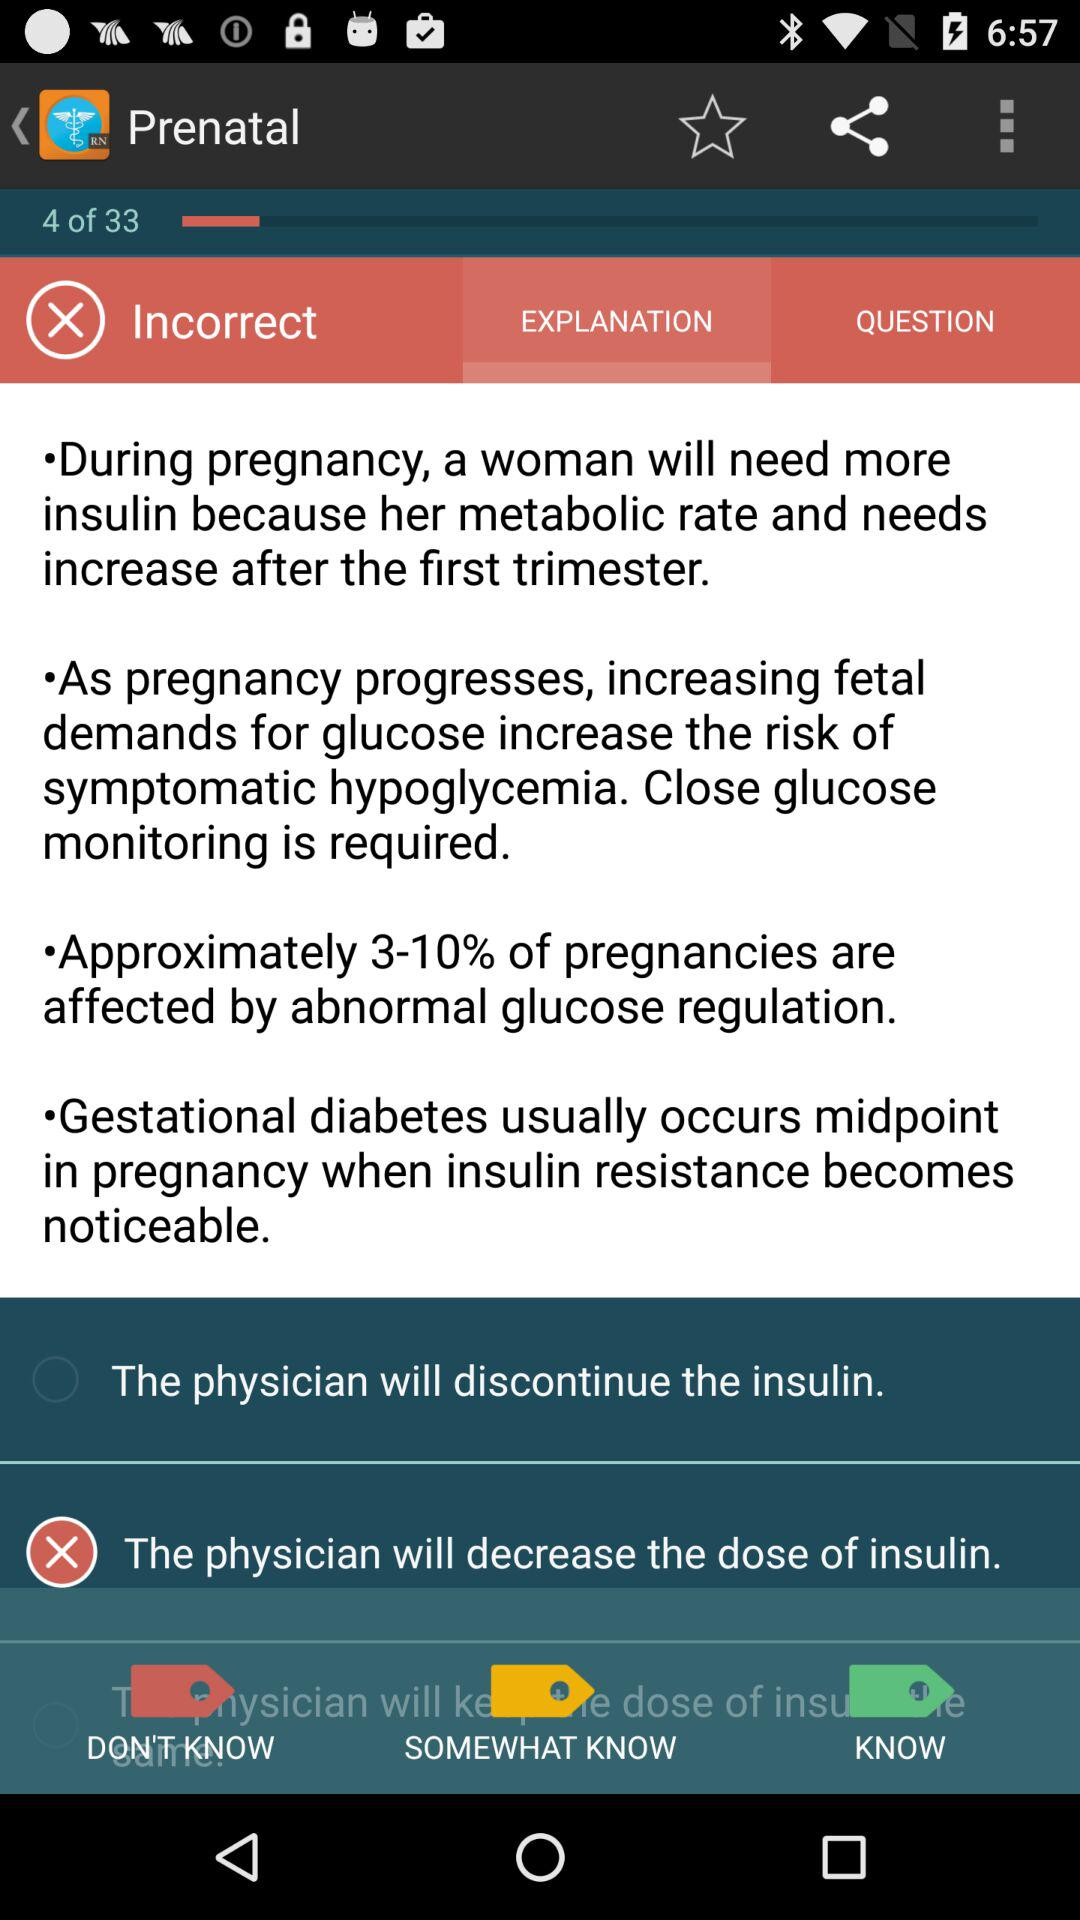How many of the statements end with the physician decreasing the dose of insulin?
Answer the question using a single word or phrase. 1 